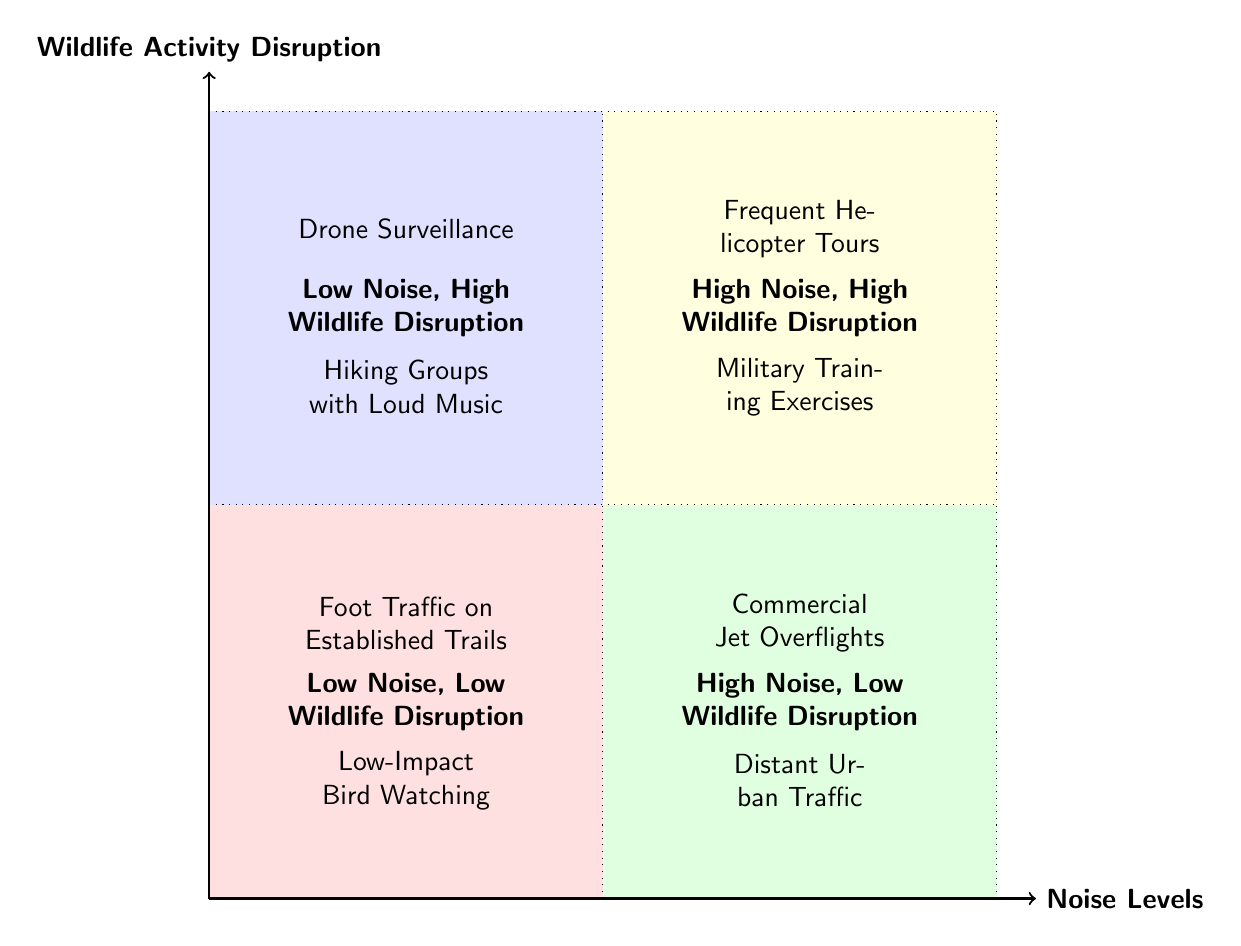What is located in the "High Noise, High Wildlife Disruption" quadrant? The diagram shows two items in this quadrant: "Frequent Helicopter Tours" and "Military Training Exercises".
Answer: Frequent Helicopter Tours, Military Training Exercises How many activities are listed in the "Low Noise, Low Wildlife Disruption" quadrant? There are two activities listed in this quadrant: "Foot Traffic on Established Trails" and "Low-Impact Bird Watching".
Answer: 2 Which activity has the highest disruption in the "Low Noise" category? In the "Low Noise" category, "Drone Surveillance (close to the ground)" appears in the "Low Noise, High Wildlife Disruption" quadrant, indicating it has the highest disruption among the low noise activities.
Answer: Drone Surveillance What can be inferred about commercial jet overflights regarding wildlife disruption? Commercial jet overflights are placed in the "High Noise, Low Wildlife Disruption" quadrant, indicating they produce high noise but have a lesser effect on wildlife disruption compared to other high noise activities.
Answer: High Noise, Low Wildlife Disruption Which activity shows both high noise and low wildlife disruption? The activity that fits this criteria is "Commercial Jet Overflights", as it is positioned in the "High Noise, Low Wildlife Disruption" quadrant.
Answer: Commercial Jet Overflights What is the relationship between noise levels and wildlife disruption for hiking groups? Hiking groups with loud music are placed in the "Low Noise, High Wildlife Disruption" quadrant, suggesting that even low noise levels can significantly disrupt wildlife activity due to loud behavior.
Answer: Low Noise, High Wildlife Disruption Which quadrant contains activities primarily caused by human recreation? The "Low Noise, High Wildlife Disruption" quadrant contains activities caused by human recreation, such as "Drone Surveillance" and "Hiking Groups with Loud Music".
Answer: Low Noise, High Wildlife Disruption How does distant urban traffic affect wildlife disruption? Distant urban traffic is in the "High Noise, Low Wildlife Disruption" quadrant, indicating that while it generates high noise, it does not significantly disrupt wildlife activities.
Answer: High Noise, Low Wildlife Disruption 